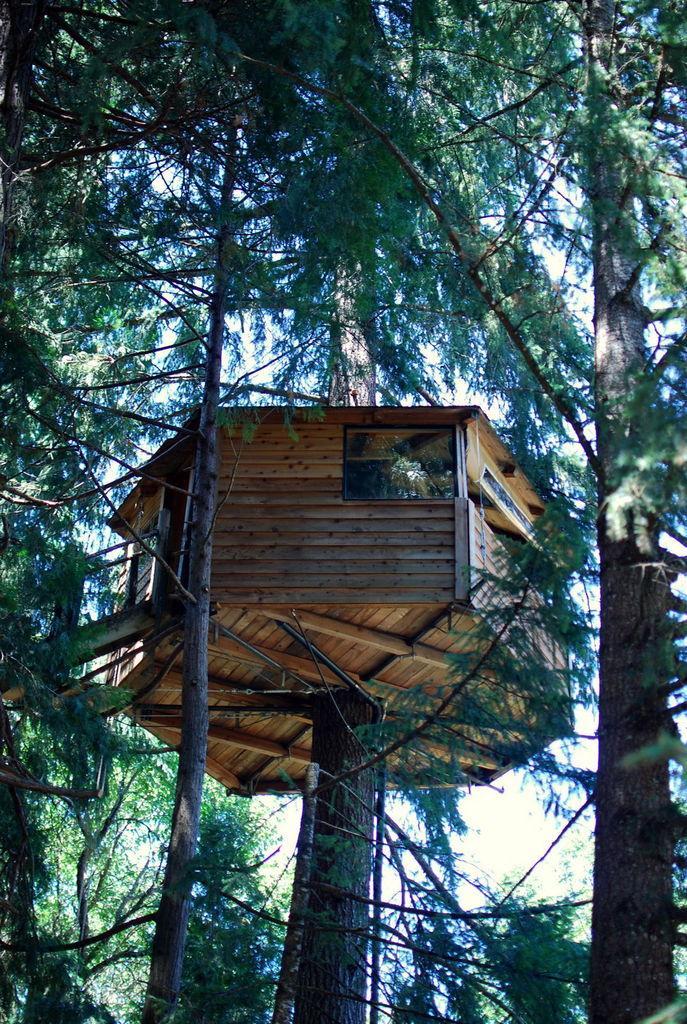Can you describe this image briefly? In this image we can see the wooden tree house, we can see trees and the sky in the background. 